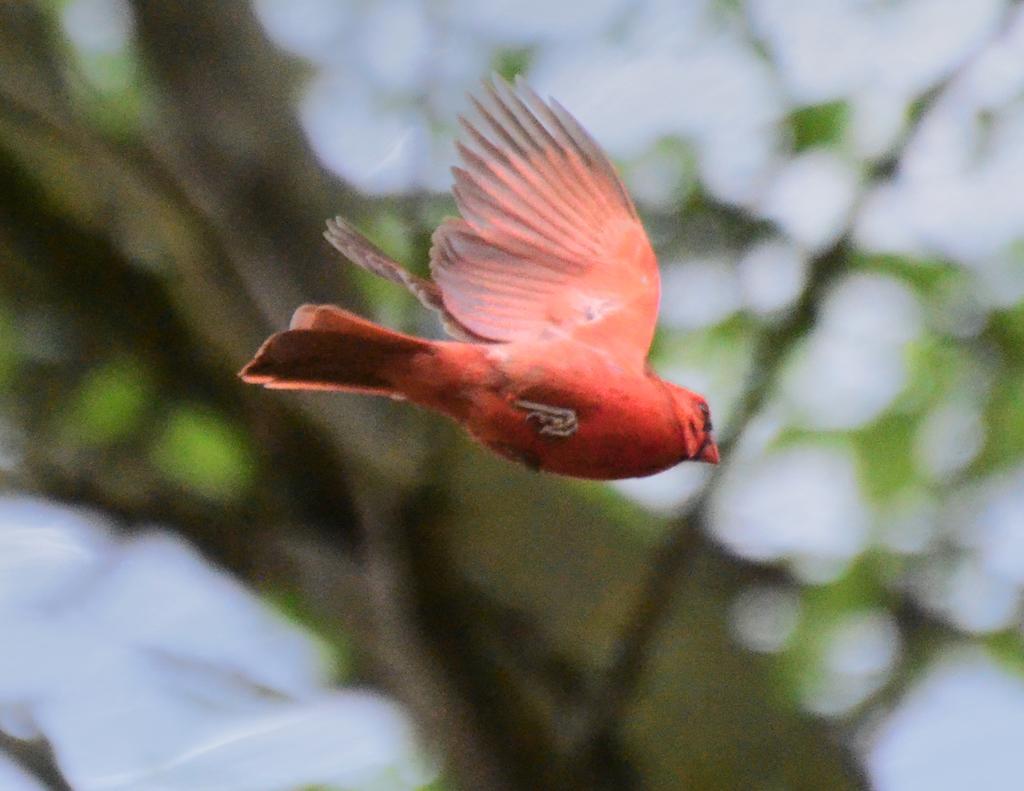Please provide a concise description of this image. In this image we can see a bird flying in the air. 